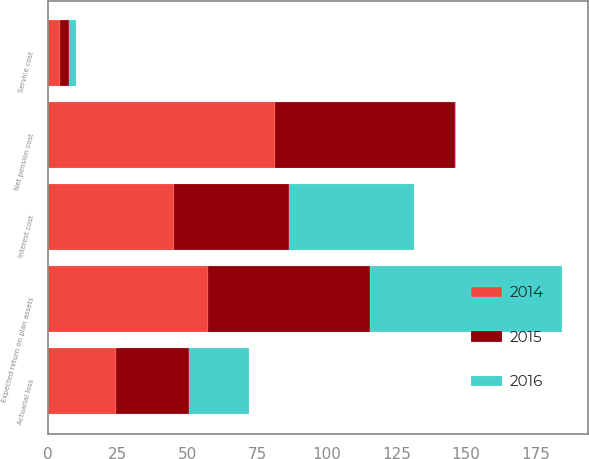Convert chart to OTSL. <chart><loc_0><loc_0><loc_500><loc_500><stacked_bar_chart><ecel><fcel>Service cost<fcel>Interest cost<fcel>Expected return on plan assets<fcel>Actuarial loss<fcel>Net pension cost<nl><fcel>2016<fcel>2.7<fcel>45.1<fcel>69.1<fcel>21.8<fcel>0.4<nl><fcel>2015<fcel>3.2<fcel>41.3<fcel>58<fcel>26.2<fcel>64.7<nl><fcel>2014<fcel>4.1<fcel>45.1<fcel>57.5<fcel>24.2<fcel>81.3<nl></chart> 